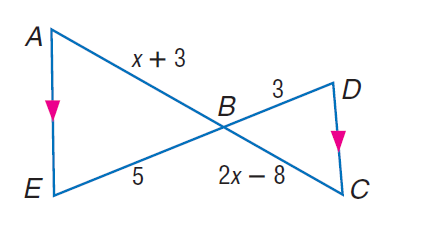Question: Find A B.
Choices:
A. 4
B. 6
C. 10
D. 11
Answer with the letter. Answer: C 